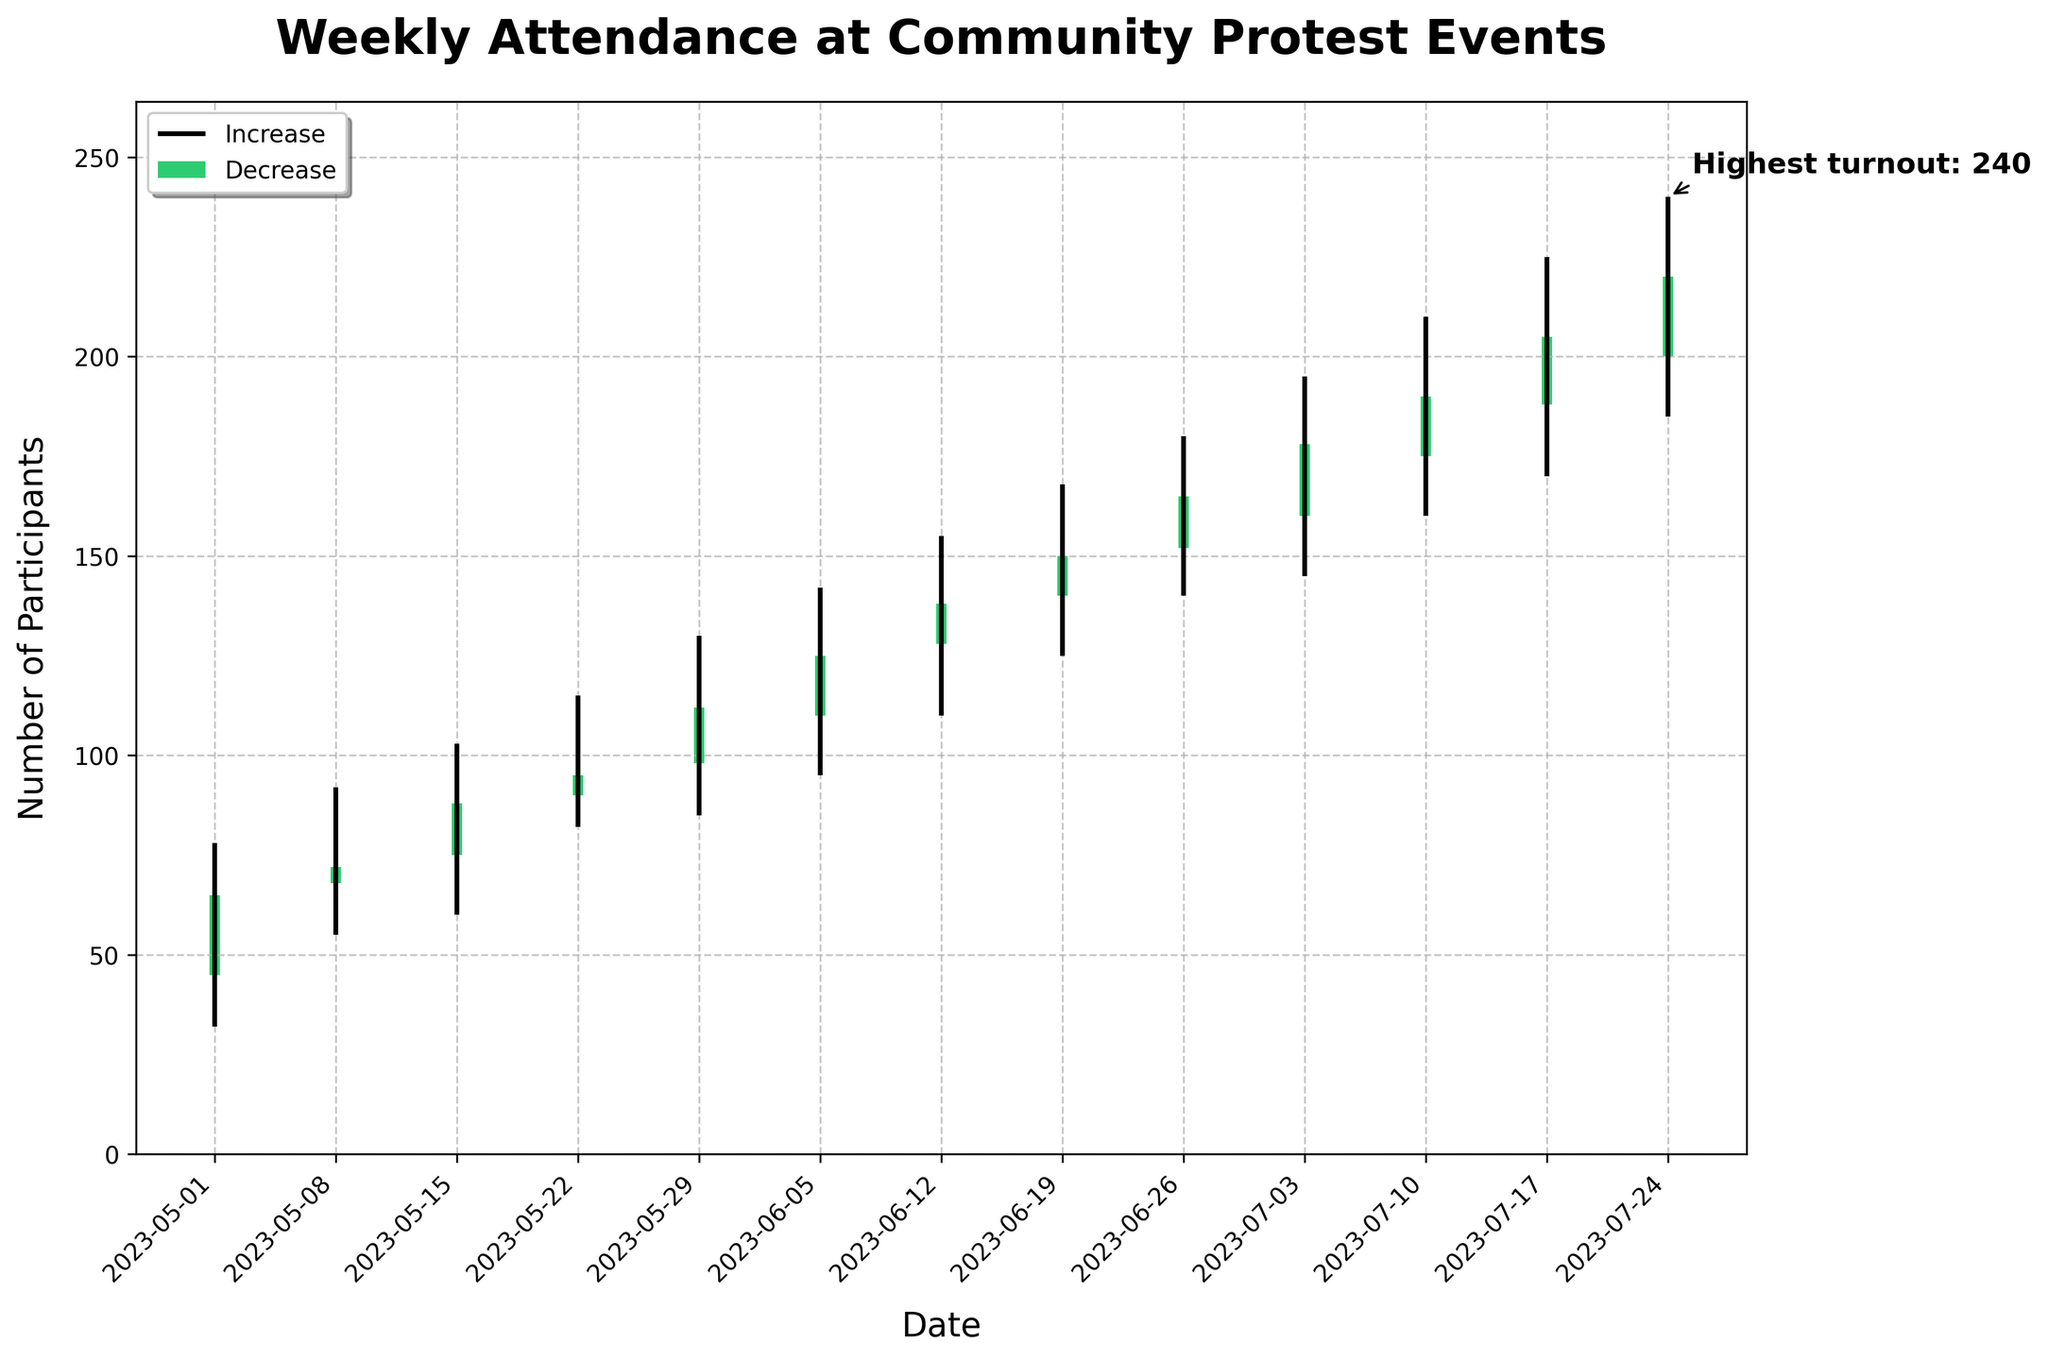what is the title of the chart? The title is usually found at the top part of a chart and provides a quick summary of what the visualization represents. In this case, the title is displayed prominently in bold text at the top of the figure.
Answer: Weekly Attendance at Community Protest Events what are the units on the y-axis? The y-axis label indicates the units being measured. It is typically located along the vertical axis. Here, the label is "Number of Participants" which tells us that the y-axis measures attendance counts.
Answer: Number of Participants what was the highest attendance recorded and when? To find the highest attendance, we look for the highest point on the y-axis reached by the vertical lines representing weekly high values. The figure marks the highest point with a label "Highest turnout" and an annotation pointing to the corresponding date.
Answer: 240 on 2023-07-24 which weeks showed an increase in attendance? An increase in attendance is indicated by green bars, where the close value is higher than the open value. By visually inspecting the colors of the bars, we can identify the weeks that have green bars.
Answer: All weeks (2023-05-01 to 2023-07-24) what was the lowest turnout and in which week did it occur? The lowest turnout is found by looking at the minimum value on the y-axis reached by the vertical lines representing weekly low values. This low value can be directly read off the figure at the lowest point of the downward-extending lines.
Answer: 32 on week of 2023-05-01 compare the attendance between the week of 2023-06-12 and 2023-06-26 To compare, check the heights of the bars and corresponding high and low points for the weeks 2023-06-12 and 2023-06-26. The heights indicate the relative attendance; 2023-06-26 has higher highs and lows compared to 2023-06-12.
Answer: Week of 2023-06-26 had higher attendance what is the average closing attendance across all weeks? Average closing attendance is calculated by summing up all the close values and dividing by the number of weeks. The close values are: 65, 72, 88, 95, 112, 125, 138, 150, 165, 178, 190, 205, 220. Sum these values and divide by 13. (65+72+88+95+112+125+138+150+165+178+190+205+220) / 13 ≈ 140.15
Answer: 140.15 what week shows the most volatility in attendance? Volatility refers to the range between high and low turnouts. Calculate the difference between high and low for each week, and determine which has the highest range: For 2023-07-24: 240 - 185 = 55. Check this across all weeks, with the highest range indicating the most volatility.
Answer: 2023-07-24 with a range of 55 